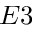Convert formula to latex. <formula><loc_0><loc_0><loc_500><loc_500>E 3</formula> 